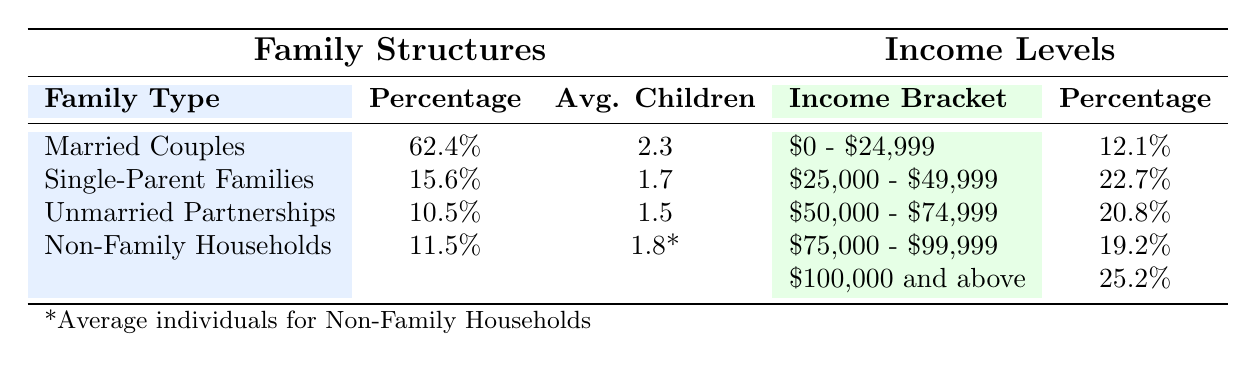What percentage of families in Chardon, Ohio are married couples? The table shows that the percentage of married couples as a family structure is clearly listed as 62.4%.
Answer: 62.4% How many average children do single-parent families have? According to the table, single-parent families have an average of 1.7 children listed in the average children column under family structures.
Answer: 1.7 What is the income bracket with the highest percentage in Chardon, Ohio? The table provides data on various income brackets, with "$100,000 and above" showing the highest percentage of 25.2% listed under income levels.
Answer: $100,000 and above Is the percentage of unmarried partnerships greater than that of single-parent families? The percentage of unmarried partnerships is 10.5%, while single-parent families have a percentage of 15.6%. Since 10.5% is less than 15.6%, the statement is false.
Answer: No What is the combined percentage of families earning less than $50,000? To find this, we add the percentages of both the "$0 - $24,999" bracket which is 12.1%, and the "$25,000 - $49,999" bracket which is 22.7%. The total is 12.1 + 22.7 = 34.8%.
Answer: 34.8% What proportion of non-family households can be expected to have 1.8 individuals on average? The average individuals for non-family households is explicitly listed as 1.8 in the average individuals column.
Answer: 1.8 How does the average number of children in married couples compare to that in unmarried partnerships? The average number of children in married couples is 2.3, while in unmarried partnerships it is 1.5. By comparing these two values, we see that 2.3 is greater than 1.5.
Answer: Married couples have more children What is the percentage difference between the lowest and highest income brackets? The lowest income bracket ($0 - $24,999) has a percentage of 12.1%, while the highest income bracket ($100,000 and above) is 25.2%. The difference is calculated as 25.2 - 12.1 = 13.1%.
Answer: 13.1% 